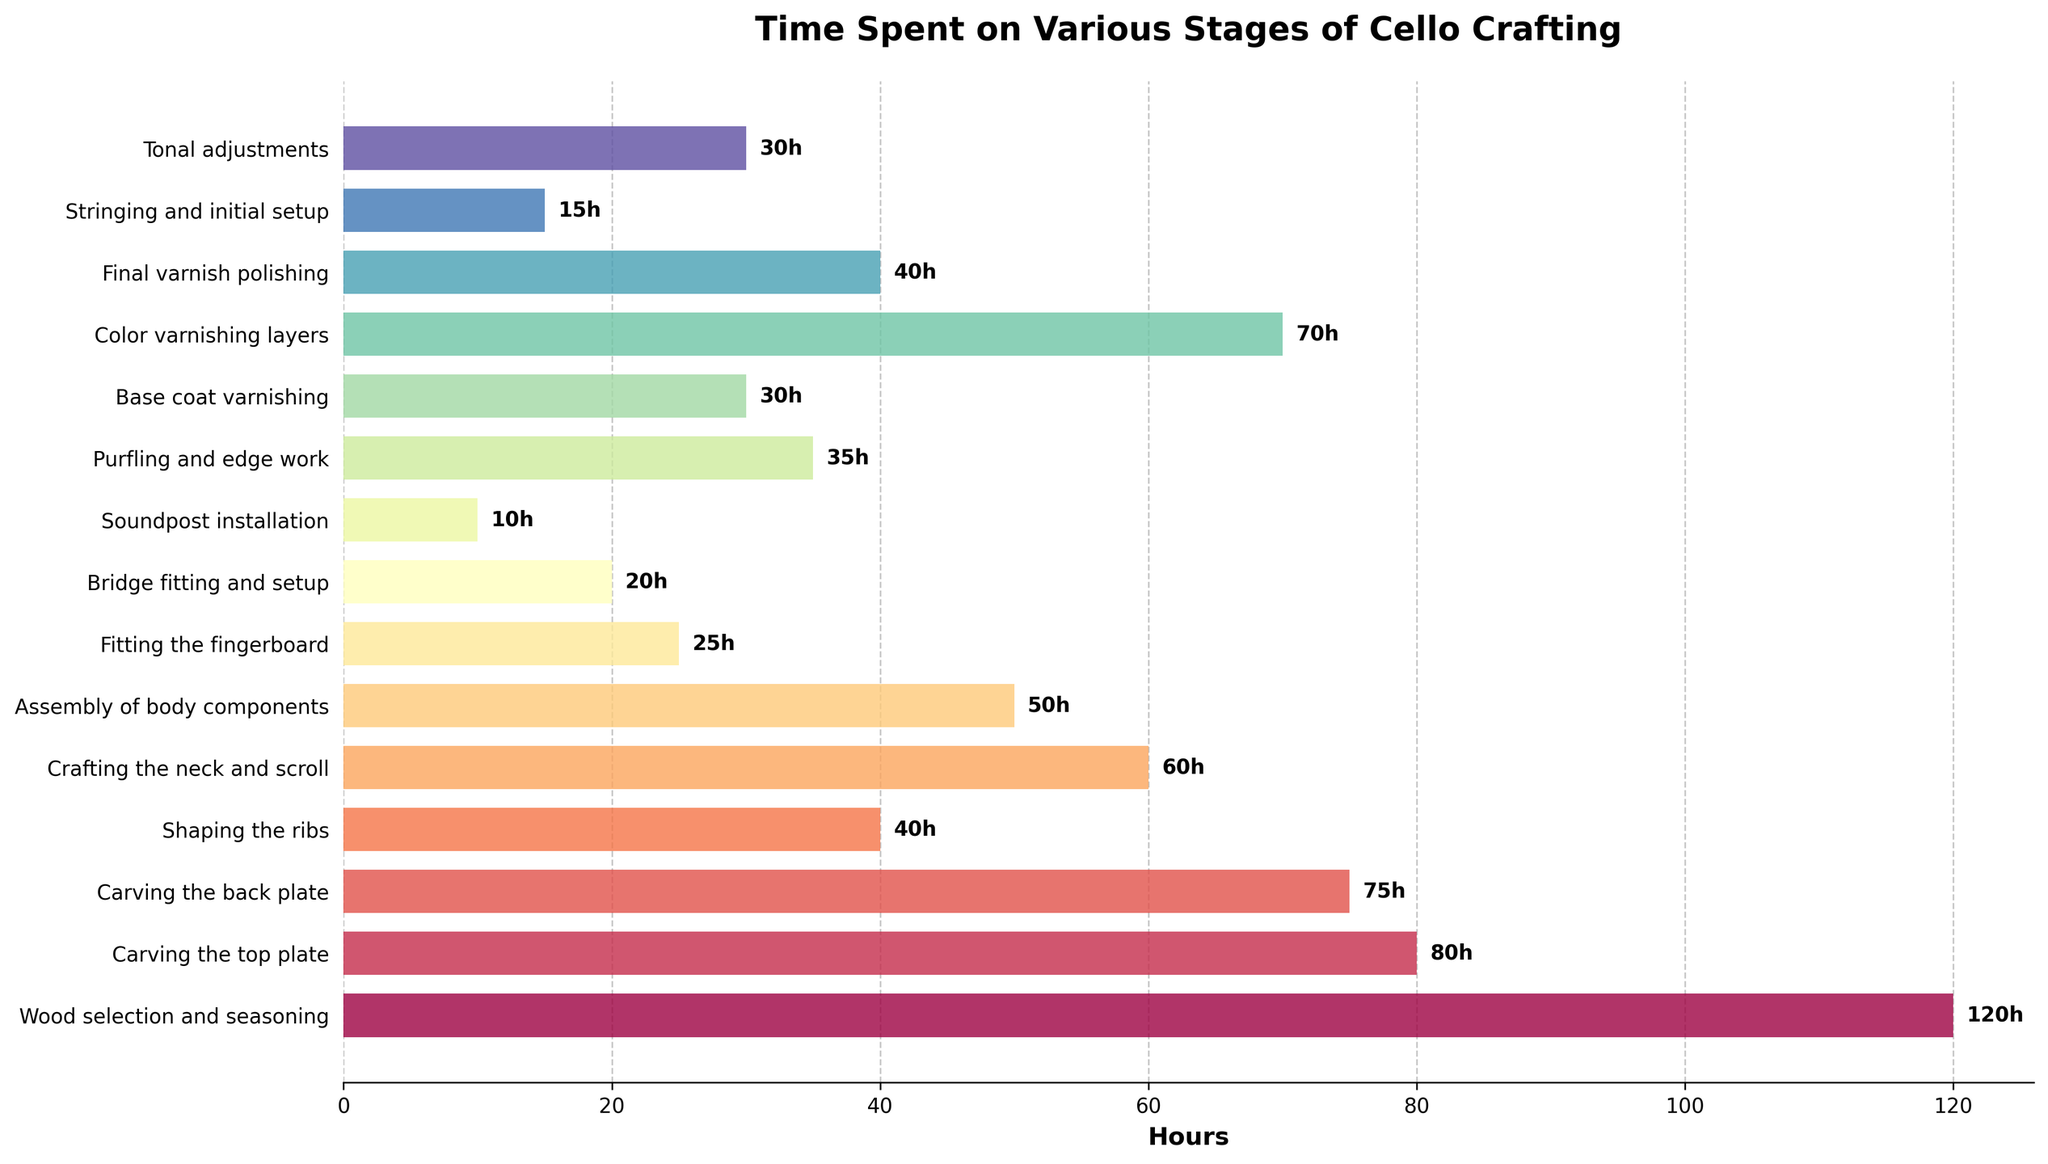What is the total time spent on varnishing stages? Varnishing includes "Base coat varnishing" (30 hours), "Color varnishing layers" (70 hours), and "Final varnish polishing" (40 hours). Summing these times gives 30 + 70 + 40 = 140 hours
Answer: 140 hours Which stage requires the least amount of time? The stage with the smallest bar on the chart represents the least time. "Soundpost installation" has the least time at 10 hours
Answer: Soundpost installation What is the difference in time between carving the top plate and carving the back plate? Carving the top plate takes 80 hours, and carving the back plate takes 75 hours. The difference is 80 - 75 = 5 hours
Answer: 5 hours How much more time is spent on wood selection and seasoning compared to final varnish polishing? Wood selection and seasoning is 120 hours, and final varnish polishing is 40 hours. The difference is 120 - 40 = 80 hours
Answer: 80 hours What stages require more than 50 hours? The stages above 50 hours are easily identifiable by their longer bars. These are: "Wood selection and seasoning" (120 hours), "Carving the top plate" (80 hours), "Carving the back plate" (75 hours), "Crafting the neck and scroll" (60 hours), and "Color varnishing layers" (70 hours)
Answer: Wood selection and seasoning, Carving the top plate, Carving the back plate, Crafting the neck and scroll, Color varnishing layers Which stage takes the most amount of time? The stage with the longest bar represents the most time. "Wood selection and seasoning" has the longest bar at 120 hours
Answer: Wood selection and seasoning What is the combined time for the assembly of body components, fitting the fingerboard, and bridge fitting and setup? Assembly of body components is 50 hours, fitting the fingerboard is 25 hours, and bridge fitting and setup is 20 hours. Summing these times gives 50 + 25 + 20 = 95 hours
Answer: 95 hours How does the time spent on shaping the ribs compare to purfling and edge work? Shaping the ribs takes 40 hours, while purfling and edge work takes 35 hours. Therefore, shaping the ribs requires 40 - 35 = 5 hours more
Answer: 5 hours more 